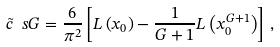<formula> <loc_0><loc_0><loc_500><loc_500>\tilde { c } _ { \ } s G = \frac { 6 } { \pi ^ { 2 } } \left [ L \left ( x _ { 0 } \right ) - \frac { 1 } { G + 1 } L \left ( x _ { 0 } ^ { G + 1 } \right ) \right ] \, ,</formula> 